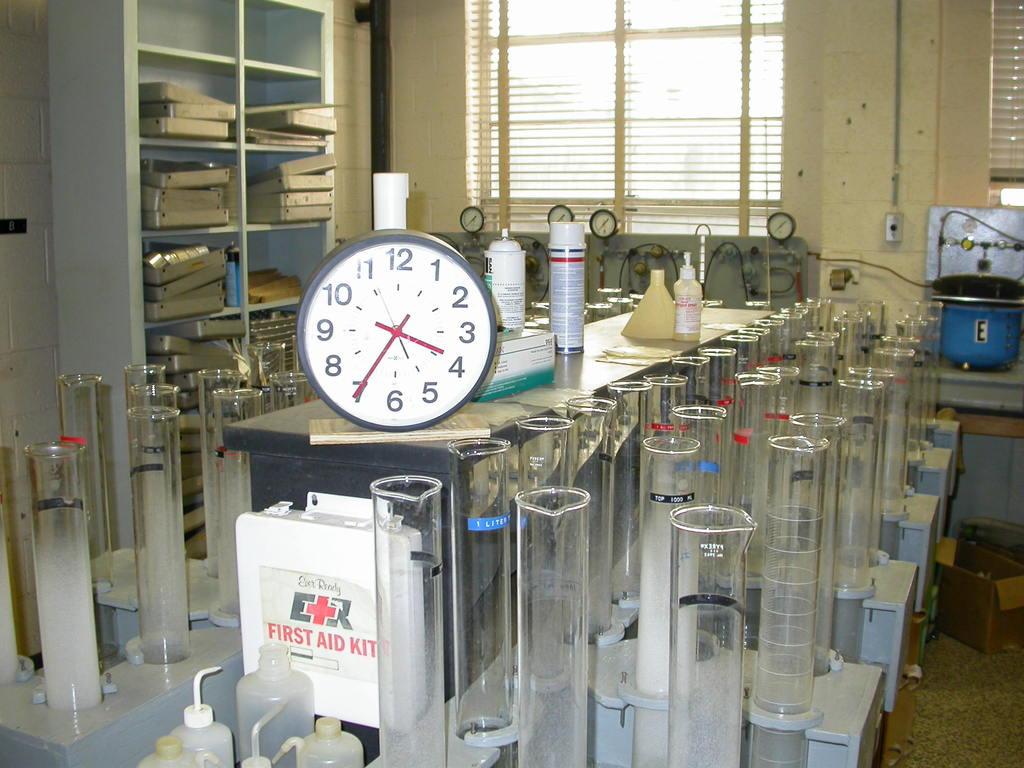What kind of kit is sitting below the clock?
Give a very brief answer. First aid. Does the clock read 3:35?
Your answer should be compact. Yes. 